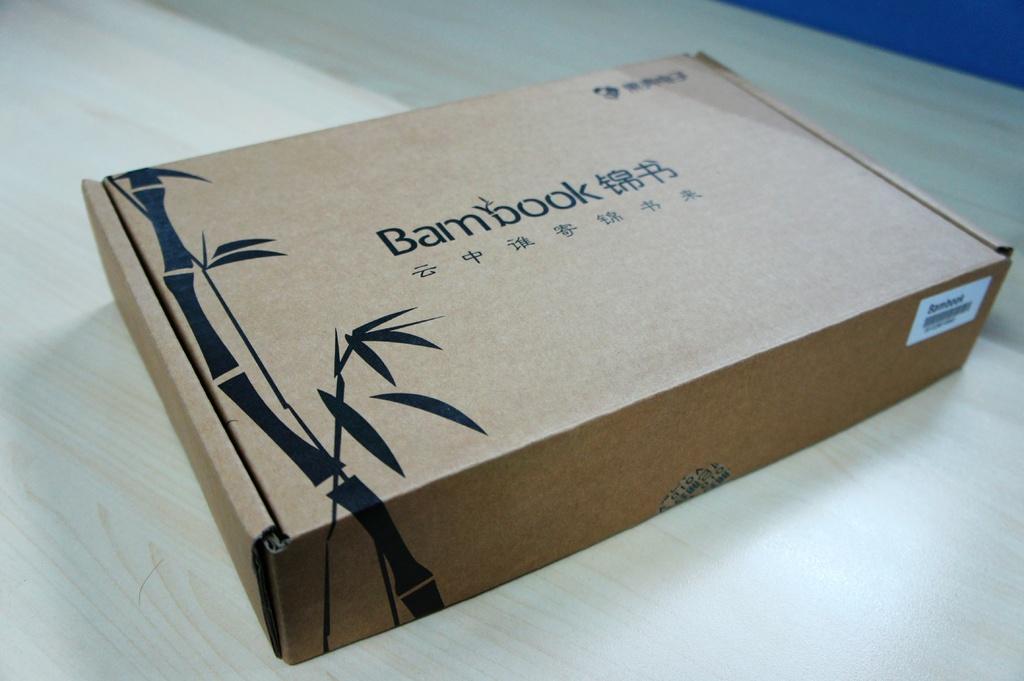What company did this box come from?
Give a very brief answer. Bambook. Some in the item?
Keep it short and to the point. Not a question. 